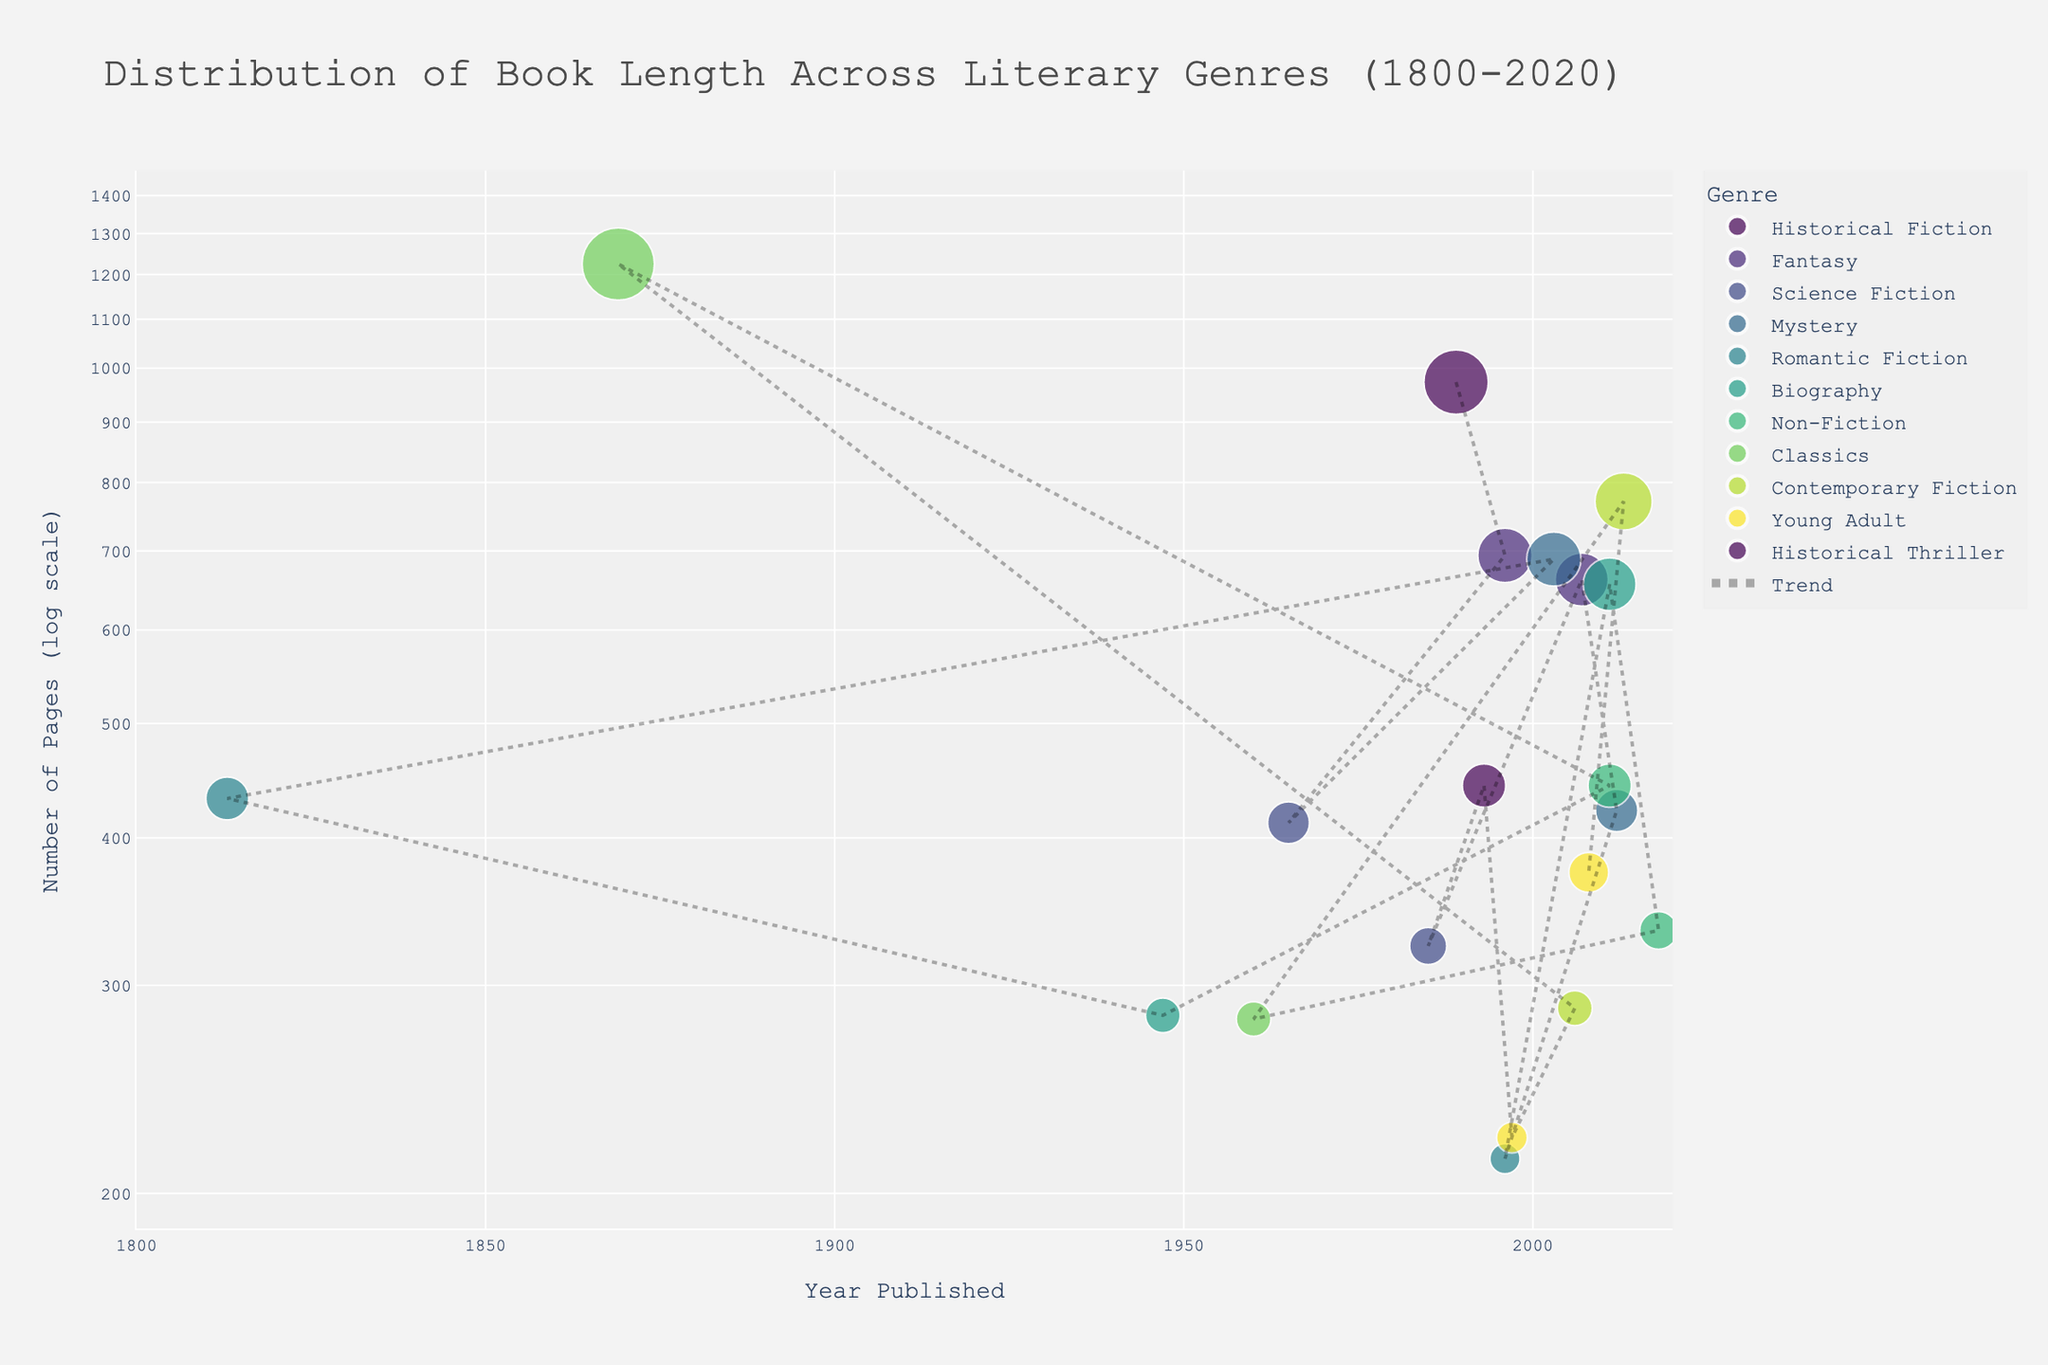What is the title of the figure? The title is usually displayed at the top of the figure. In this case, it reads "Distribution of Book Length Across Literary Genres (1800-2020)"
Answer: Distribution of Book Length Across Literary Genres (1800-2020) What does the y-axis represent, and how is it scaled? The y-axis represents the "Number of Pages" but it is scaled logarithmically (log scale), which compresses the visual distances between points of larger values.
Answer: Number of Pages (log scale) What is the range of the x-axis? The x-axis range is specified in the code: it spans from 1800 to 2020, covering the publication years of the books listed.
Answer: 1800 to 2020 Which genre appears to have the book with the largest number of pages? By inspecting the scatter plot, the book with the largest number of pages will be the highest point on the plot. This point corresponds to "War and Peace" in the Classics genre with 1,225 pages.
Answer: Classics What is the average number of pages for "Non-Fiction" genre books in the year 2011? Identify the books in the Non-Fiction genre published in 2011 and calculate their average pages. The books are "Sapiens: A Brief History of Humankind" (443 pages) and "Steve Jobs" (656 pages). The average is (443 + 656) / 2.
Answer: 549.5 By how many pages does "The Pillars of the Earth" exceed the average page count of the "Fantasy" genre in its era? First, identify the Fantasy genre books and their corresponding page counts: "A Game of Thrones" (694 pages) and "The Name of the Wind" (662 pages). Their average is (694 + 662) / 2 = 678. Compare this with "The Pillars of the Earth" (973 pages). Subtract the average pages of the Fantasy genre from "The Pillars of the Earth": 973 - 678.
Answer: 295 Which published year has more pages on average, 1996 or 2011? We count the number of books and sum their pages then divide by the number of books for each year. 1996: "A Game of Thrones" (694 pages) and "The Notebook" (214 pages). Average: (694 + 214) / 2 = 454. 2011: "Sapiens" (443 pages) and "Steve Jobs" (656 pages). Average: (443 + 656) / 2 = 549.5.
Answer: 2011 In which year was the shortest book published, and what is its genre? The shortest book will be the lowest point on the y-axis. Investigate the point, noting down the year and genre. The shortest book is "Harry Potter and the Philosopher's Stone" (Young Adult, 1997).
Answer: 1997, Young Adult How does the log scale affect the visualization of books with large differences in page numbers? A log scale condenses larger values and spreads smaller values, making differences in lower ranges more evident and reducing the apparent variance among very high values. This spreads out books with fewer pages and groups those with many pages closer together.
Answer: It makes differences in lower values more evident and compresses higher values Is there an evident trend in the number of pages over the years, and how is it represented? From the trend line added to the plot, one can observe if the number of pages is increasing, decreasing, or stable over time. In this plot, the trend line can indicate a general increase or stability.
Answer: There's a slight increase indicated by the trend line 